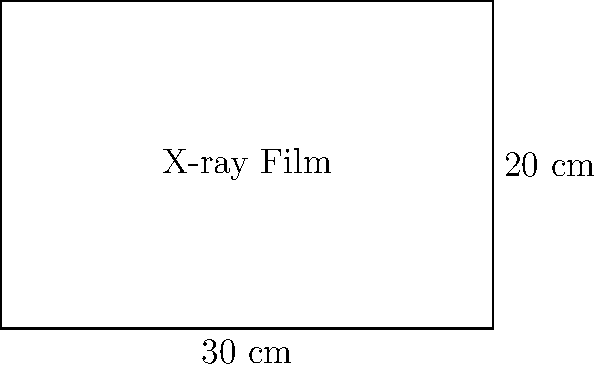In a medical imaging laboratory, a rectangular X-ray film is used for radiographic studies. The film measures 30 cm in width and 20 cm in height. Calculate the area of the X-ray film in square centimeters. How might the dimensions of this film impact the visualization of different anatomical structures in medical research combining historical radiography techniques with modern film analysis? To calculate the area of the rectangular X-ray film, we need to multiply its width by its height.

Given:
- Width of the film = 30 cm
- Height of the film = 20 cm

Step 1: Apply the formula for the area of a rectangle
Area = Width × Height

Step 2: Substitute the given values
Area = 30 cm × 20 cm

Step 3: Perform the multiplication
Area = 600 cm²

The dimensions of this film (30 cm × 20 cm) provide a standard size that has been commonly used in medical imaging. This size allows for:

1. Visualization of larger anatomical structures, such as chest X-rays or abdominal radiographs.
2. Comparison of historical radiographic techniques with modern digital imaging methods.
3. Analysis of how film size influenced diagnostic capabilities in different eras of medical history.
4. Study of the evolution of X-ray film technology and its impact on medical practice.

Researchers combining medicine and film studies can use this standard size to:
- Examine how framing and composition in X-ray images evolved over time.
- Investigate the limitations and advantages of film-based radiography compared to digital systems.
- Explore how film dimensions affected the portrayal of human anatomy in medical education and public health campaigns.
Answer: 600 cm² 